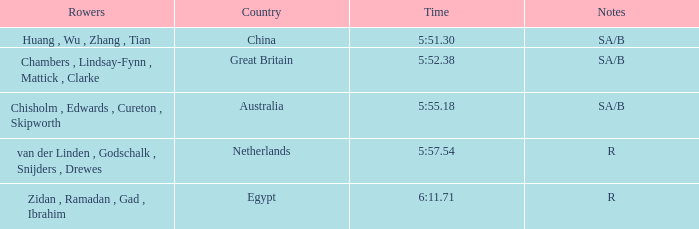What is the country with sa/b as its notes and 5:51.30 as its time? China. 